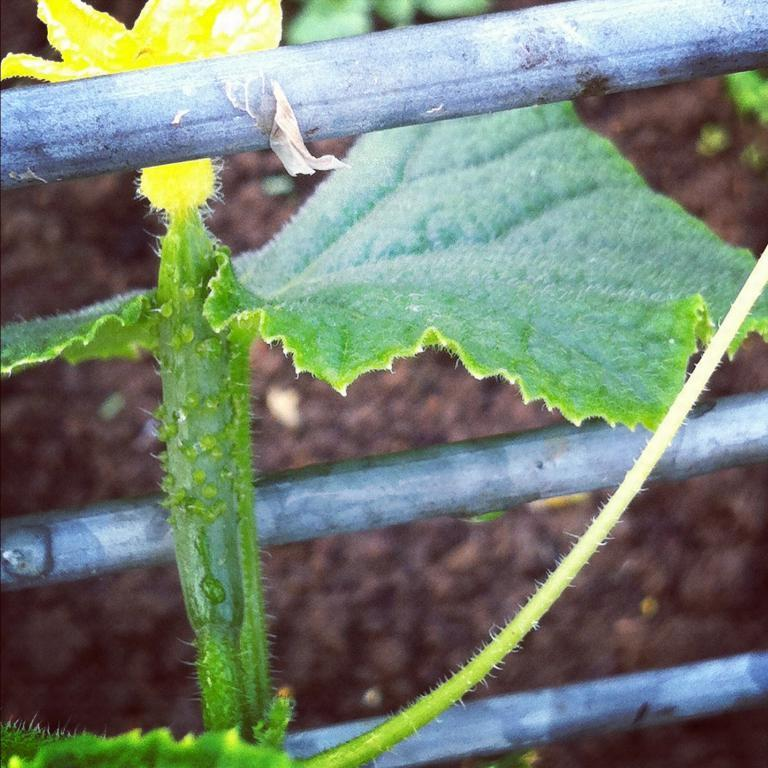What can be seen in the middle of the picture? There is a railing in the middle of the picture. What type of vegetation is present in the image? Leaves are present in the image. What kind of flower can be seen in the image? There is a yellow color flower in the image. How would you describe the background of the image? The background of the image is blurred. What type of club is being used to play music in the image? There is no club or music-related activity present in the image. 